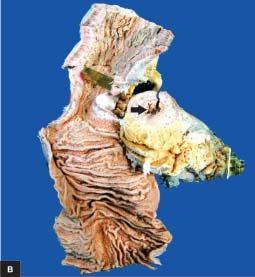s the specimen of small intestine shown in longitudinal section along with a segment in cross section?
Answer the question using a single word or phrase. Yes 